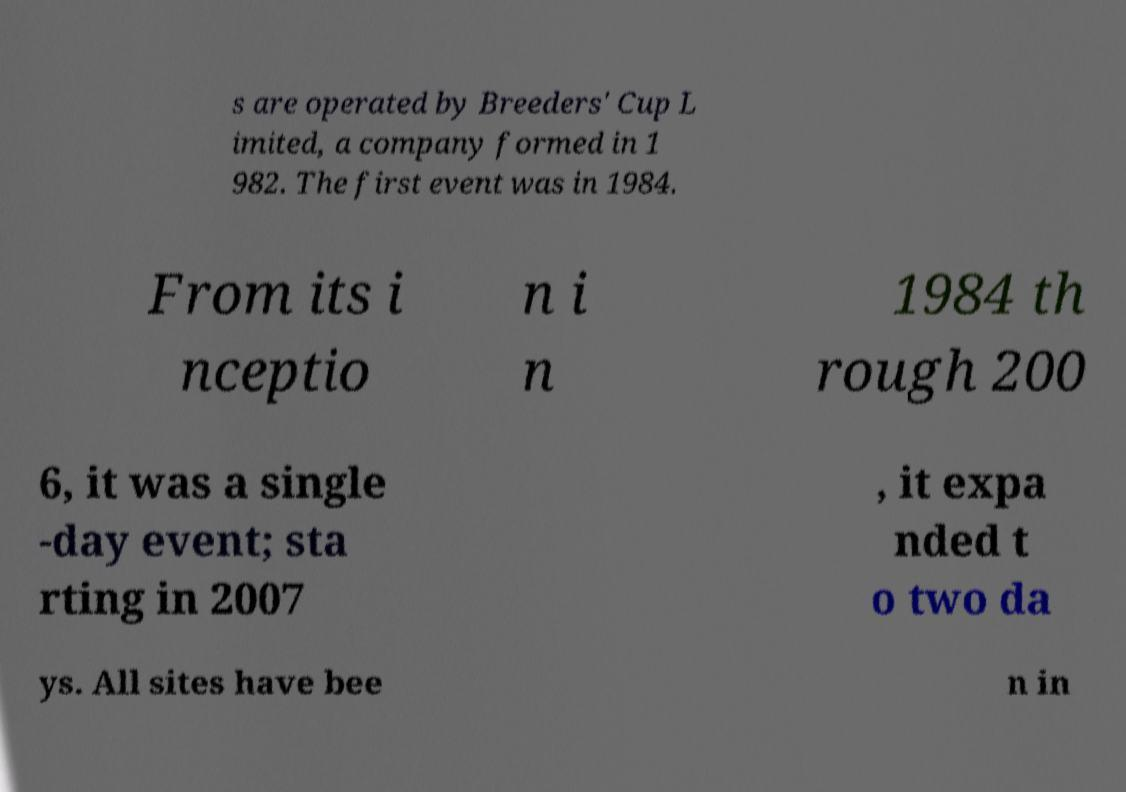Could you assist in decoding the text presented in this image and type it out clearly? s are operated by Breeders' Cup L imited, a company formed in 1 982. The first event was in 1984. From its i nceptio n i n 1984 th rough 200 6, it was a single -day event; sta rting in 2007 , it expa nded t o two da ys. All sites have bee n in 